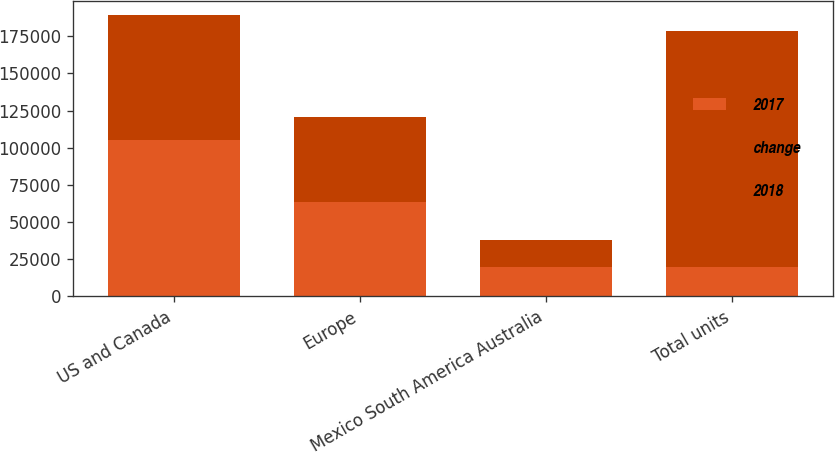Convert chart. <chart><loc_0><loc_0><loc_500><loc_500><stacked_bar_chart><ecel><fcel>US and Canada<fcel>Europe<fcel>Mexico South America Australia<fcel>Total units<nl><fcel>2017<fcel>105300<fcel>63800<fcel>20000<fcel>20000<nl><fcel>change<fcel>84200<fcel>57100<fcel>17600<fcel>158900<nl><fcel>2018<fcel>25<fcel>12<fcel>14<fcel>19<nl></chart> 